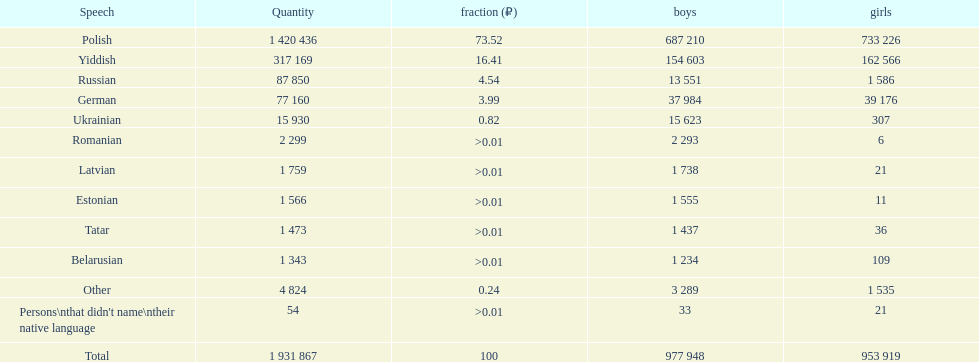Which language was spoken by the fewest females? Romanian. 